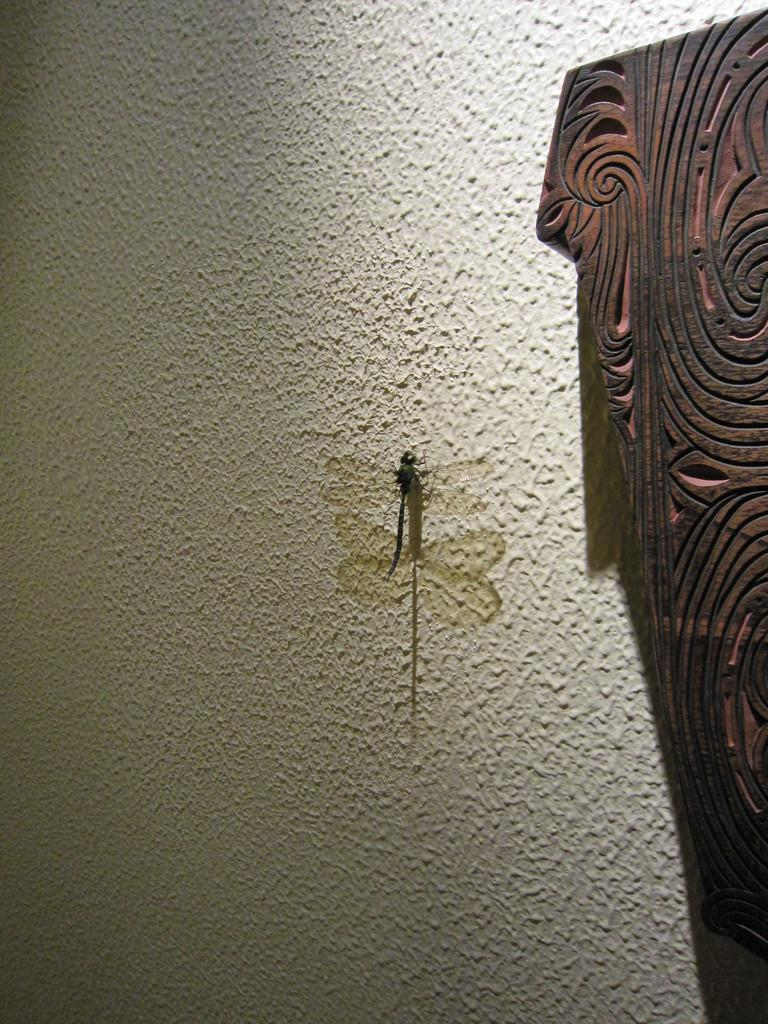Where was the image taken? The image is taken indoors. What can be seen in the middle of the image? There is a wall in the middle of the image. What is on the wall in the image? There is a dragonfly on the wall. What type of object can be seen on the right side of the image? There is a wooden object on the right side of the image. What type of friction can be observed between the dragonfly and the wall in the image? There is no indication of friction between the dragonfly and the wall in the image, as it is a static image and not a video. --- Facts: 1. There is a person sitting on a chair in the image. 2. The person is holding a book. 3. There is a table next to the chair. 4. There is a lamp on the table. 5. The background of the image is dark. Absurd Topics: parrot, ocean, bicycle Conversation: What is the person in the image doing? The person is sitting on a chair in the image. What is the person holding in the image? The person is holding a book. What is located next to the chair in the image? There is a table next to the chair in the image. What is on the table in the image? There is a lamp on the table in the image. How would you describe the lighting in the image? The background of the image is dark, which suggests that the lighting is dim or low. Reasoning: Let's think step by step in order to produce the conversation. We start by identifying the main subject in the image, which is the person sitting on a chair. Then, we describe what the person is holding, which is a book. Next, we mention the table and lamp, which provide context for the scene. Finally, we describe the overall lighting in the image based on the dark background. Absurd Question/Answer: Can you see a parrot flying over the ocean in the image? There is no parrot or ocean present in the image; it features a person sitting on a chair with a book and a table with a lamp. --- Facts: 1. There is a person standing on a bridge in the image. 2. The person is holding a camera. 3. The bridge is over a river. 4. There are trees on both sides of the river. 5. The sky is visible in the image. Absurd Topics: elephant, snow, umbrella Conversation: What is the person in the image doing? The person is standing on a bridge in the image. What is the person holding in the image? The person is holding a camera. What is the bridge crossing in the image? The bridge is over a river 